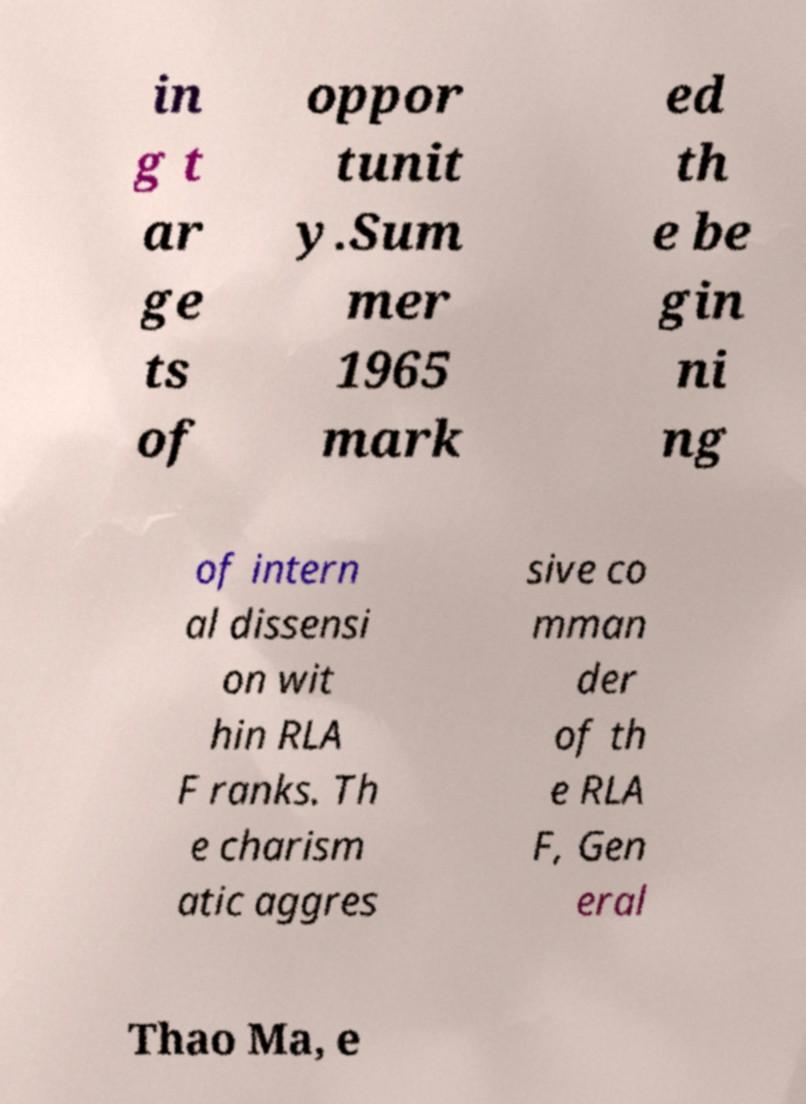Could you extract and type out the text from this image? in g t ar ge ts of oppor tunit y.Sum mer 1965 mark ed th e be gin ni ng of intern al dissensi on wit hin RLA F ranks. Th e charism atic aggres sive co mman der of th e RLA F, Gen eral Thao Ma, e 